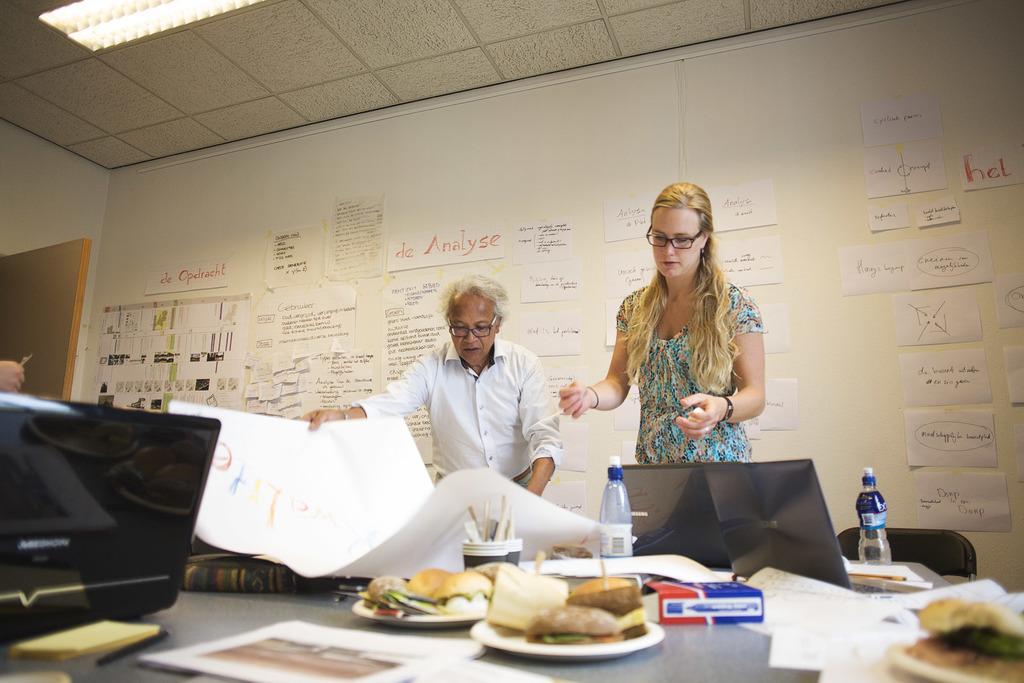How would you summarize this image in a sentence or two? In this picture we can see two persons standing on the floor. This is the table. On the table there are laptop, papers, plates and food. And this is the chair. On the background there is a wall. And these are the posters. 